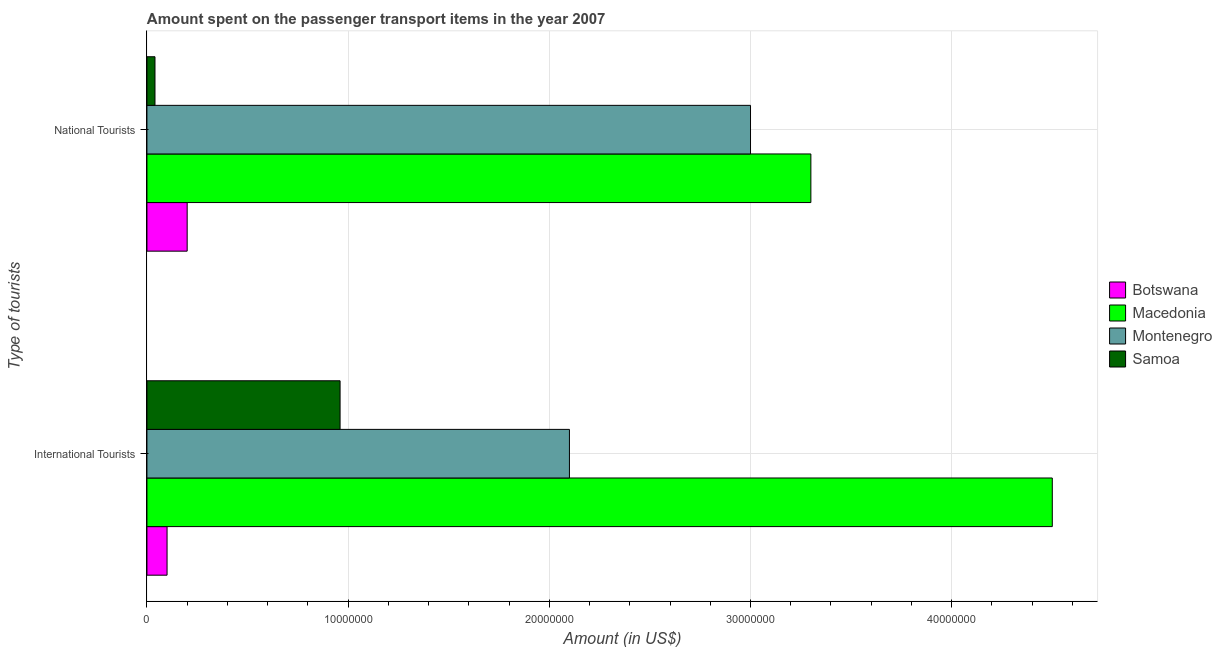How many groups of bars are there?
Keep it short and to the point. 2. Are the number of bars on each tick of the Y-axis equal?
Your answer should be very brief. Yes. How many bars are there on the 2nd tick from the top?
Your answer should be compact. 4. How many bars are there on the 1st tick from the bottom?
Make the answer very short. 4. What is the label of the 2nd group of bars from the top?
Provide a short and direct response. International Tourists. What is the amount spent on transport items of national tourists in Samoa?
Provide a succinct answer. 4.00e+05. Across all countries, what is the maximum amount spent on transport items of national tourists?
Offer a terse response. 3.30e+07. Across all countries, what is the minimum amount spent on transport items of national tourists?
Your answer should be very brief. 4.00e+05. In which country was the amount spent on transport items of national tourists maximum?
Your response must be concise. Macedonia. In which country was the amount spent on transport items of international tourists minimum?
Your answer should be very brief. Botswana. What is the total amount spent on transport items of international tourists in the graph?
Your answer should be compact. 7.66e+07. What is the difference between the amount spent on transport items of national tourists in Macedonia and that in Botswana?
Give a very brief answer. 3.10e+07. What is the difference between the amount spent on transport items of national tourists in Samoa and the amount spent on transport items of international tourists in Macedonia?
Your answer should be compact. -4.46e+07. What is the average amount spent on transport items of international tourists per country?
Your answer should be compact. 1.92e+07. What is the difference between the amount spent on transport items of international tourists and amount spent on transport items of national tourists in Botswana?
Keep it short and to the point. -1.00e+06. What is the ratio of the amount spent on transport items of national tourists in Samoa to that in Montenegro?
Make the answer very short. 0.01. Is the amount spent on transport items of international tourists in Montenegro less than that in Botswana?
Your answer should be compact. No. What does the 4th bar from the top in National Tourists represents?
Provide a succinct answer. Botswana. What does the 4th bar from the bottom in International Tourists represents?
Give a very brief answer. Samoa. Are all the bars in the graph horizontal?
Your response must be concise. Yes. How many countries are there in the graph?
Your answer should be very brief. 4. What is the difference between two consecutive major ticks on the X-axis?
Make the answer very short. 1.00e+07. Are the values on the major ticks of X-axis written in scientific E-notation?
Your response must be concise. No. Where does the legend appear in the graph?
Provide a succinct answer. Center right. How many legend labels are there?
Offer a very short reply. 4. How are the legend labels stacked?
Your answer should be compact. Vertical. What is the title of the graph?
Ensure brevity in your answer.  Amount spent on the passenger transport items in the year 2007. What is the label or title of the X-axis?
Offer a very short reply. Amount (in US$). What is the label or title of the Y-axis?
Offer a very short reply. Type of tourists. What is the Amount (in US$) in Botswana in International Tourists?
Provide a short and direct response. 1.00e+06. What is the Amount (in US$) in Macedonia in International Tourists?
Make the answer very short. 4.50e+07. What is the Amount (in US$) of Montenegro in International Tourists?
Provide a succinct answer. 2.10e+07. What is the Amount (in US$) of Samoa in International Tourists?
Your answer should be compact. 9.60e+06. What is the Amount (in US$) in Botswana in National Tourists?
Ensure brevity in your answer.  2.00e+06. What is the Amount (in US$) of Macedonia in National Tourists?
Offer a terse response. 3.30e+07. What is the Amount (in US$) of Montenegro in National Tourists?
Your answer should be compact. 3.00e+07. What is the Amount (in US$) of Samoa in National Tourists?
Ensure brevity in your answer.  4.00e+05. Across all Type of tourists, what is the maximum Amount (in US$) in Botswana?
Offer a very short reply. 2.00e+06. Across all Type of tourists, what is the maximum Amount (in US$) in Macedonia?
Your answer should be compact. 4.50e+07. Across all Type of tourists, what is the maximum Amount (in US$) of Montenegro?
Your response must be concise. 3.00e+07. Across all Type of tourists, what is the maximum Amount (in US$) of Samoa?
Your answer should be very brief. 9.60e+06. Across all Type of tourists, what is the minimum Amount (in US$) of Botswana?
Keep it short and to the point. 1.00e+06. Across all Type of tourists, what is the minimum Amount (in US$) in Macedonia?
Keep it short and to the point. 3.30e+07. Across all Type of tourists, what is the minimum Amount (in US$) of Montenegro?
Make the answer very short. 2.10e+07. Across all Type of tourists, what is the minimum Amount (in US$) in Samoa?
Give a very brief answer. 4.00e+05. What is the total Amount (in US$) of Botswana in the graph?
Your answer should be compact. 3.00e+06. What is the total Amount (in US$) in Macedonia in the graph?
Keep it short and to the point. 7.80e+07. What is the total Amount (in US$) of Montenegro in the graph?
Provide a succinct answer. 5.10e+07. What is the difference between the Amount (in US$) of Botswana in International Tourists and that in National Tourists?
Offer a very short reply. -1.00e+06. What is the difference between the Amount (in US$) in Macedonia in International Tourists and that in National Tourists?
Give a very brief answer. 1.20e+07. What is the difference between the Amount (in US$) of Montenegro in International Tourists and that in National Tourists?
Make the answer very short. -9.00e+06. What is the difference between the Amount (in US$) in Samoa in International Tourists and that in National Tourists?
Offer a very short reply. 9.20e+06. What is the difference between the Amount (in US$) of Botswana in International Tourists and the Amount (in US$) of Macedonia in National Tourists?
Offer a very short reply. -3.20e+07. What is the difference between the Amount (in US$) in Botswana in International Tourists and the Amount (in US$) in Montenegro in National Tourists?
Offer a very short reply. -2.90e+07. What is the difference between the Amount (in US$) in Macedonia in International Tourists and the Amount (in US$) in Montenegro in National Tourists?
Keep it short and to the point. 1.50e+07. What is the difference between the Amount (in US$) of Macedonia in International Tourists and the Amount (in US$) of Samoa in National Tourists?
Provide a short and direct response. 4.46e+07. What is the difference between the Amount (in US$) of Montenegro in International Tourists and the Amount (in US$) of Samoa in National Tourists?
Your answer should be very brief. 2.06e+07. What is the average Amount (in US$) of Botswana per Type of tourists?
Your answer should be compact. 1.50e+06. What is the average Amount (in US$) in Macedonia per Type of tourists?
Offer a terse response. 3.90e+07. What is the average Amount (in US$) of Montenegro per Type of tourists?
Ensure brevity in your answer.  2.55e+07. What is the difference between the Amount (in US$) in Botswana and Amount (in US$) in Macedonia in International Tourists?
Keep it short and to the point. -4.40e+07. What is the difference between the Amount (in US$) in Botswana and Amount (in US$) in Montenegro in International Tourists?
Make the answer very short. -2.00e+07. What is the difference between the Amount (in US$) in Botswana and Amount (in US$) in Samoa in International Tourists?
Your answer should be compact. -8.60e+06. What is the difference between the Amount (in US$) of Macedonia and Amount (in US$) of Montenegro in International Tourists?
Give a very brief answer. 2.40e+07. What is the difference between the Amount (in US$) in Macedonia and Amount (in US$) in Samoa in International Tourists?
Provide a short and direct response. 3.54e+07. What is the difference between the Amount (in US$) of Montenegro and Amount (in US$) of Samoa in International Tourists?
Your answer should be very brief. 1.14e+07. What is the difference between the Amount (in US$) in Botswana and Amount (in US$) in Macedonia in National Tourists?
Offer a very short reply. -3.10e+07. What is the difference between the Amount (in US$) of Botswana and Amount (in US$) of Montenegro in National Tourists?
Offer a terse response. -2.80e+07. What is the difference between the Amount (in US$) of Botswana and Amount (in US$) of Samoa in National Tourists?
Provide a short and direct response. 1.60e+06. What is the difference between the Amount (in US$) in Macedonia and Amount (in US$) in Samoa in National Tourists?
Your response must be concise. 3.26e+07. What is the difference between the Amount (in US$) of Montenegro and Amount (in US$) of Samoa in National Tourists?
Keep it short and to the point. 2.96e+07. What is the ratio of the Amount (in US$) of Botswana in International Tourists to that in National Tourists?
Ensure brevity in your answer.  0.5. What is the ratio of the Amount (in US$) of Macedonia in International Tourists to that in National Tourists?
Keep it short and to the point. 1.36. What is the ratio of the Amount (in US$) of Montenegro in International Tourists to that in National Tourists?
Provide a succinct answer. 0.7. What is the ratio of the Amount (in US$) of Samoa in International Tourists to that in National Tourists?
Your answer should be compact. 24. What is the difference between the highest and the second highest Amount (in US$) of Macedonia?
Give a very brief answer. 1.20e+07. What is the difference between the highest and the second highest Amount (in US$) in Montenegro?
Offer a very short reply. 9.00e+06. What is the difference between the highest and the second highest Amount (in US$) of Samoa?
Your answer should be very brief. 9.20e+06. What is the difference between the highest and the lowest Amount (in US$) of Botswana?
Keep it short and to the point. 1.00e+06. What is the difference between the highest and the lowest Amount (in US$) in Macedonia?
Your answer should be compact. 1.20e+07. What is the difference between the highest and the lowest Amount (in US$) of Montenegro?
Your response must be concise. 9.00e+06. What is the difference between the highest and the lowest Amount (in US$) in Samoa?
Your answer should be compact. 9.20e+06. 